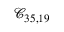Convert formula to latex. <formula><loc_0><loc_0><loc_500><loc_500>\mathcal { C } _ { 3 5 , 1 9 }</formula> 